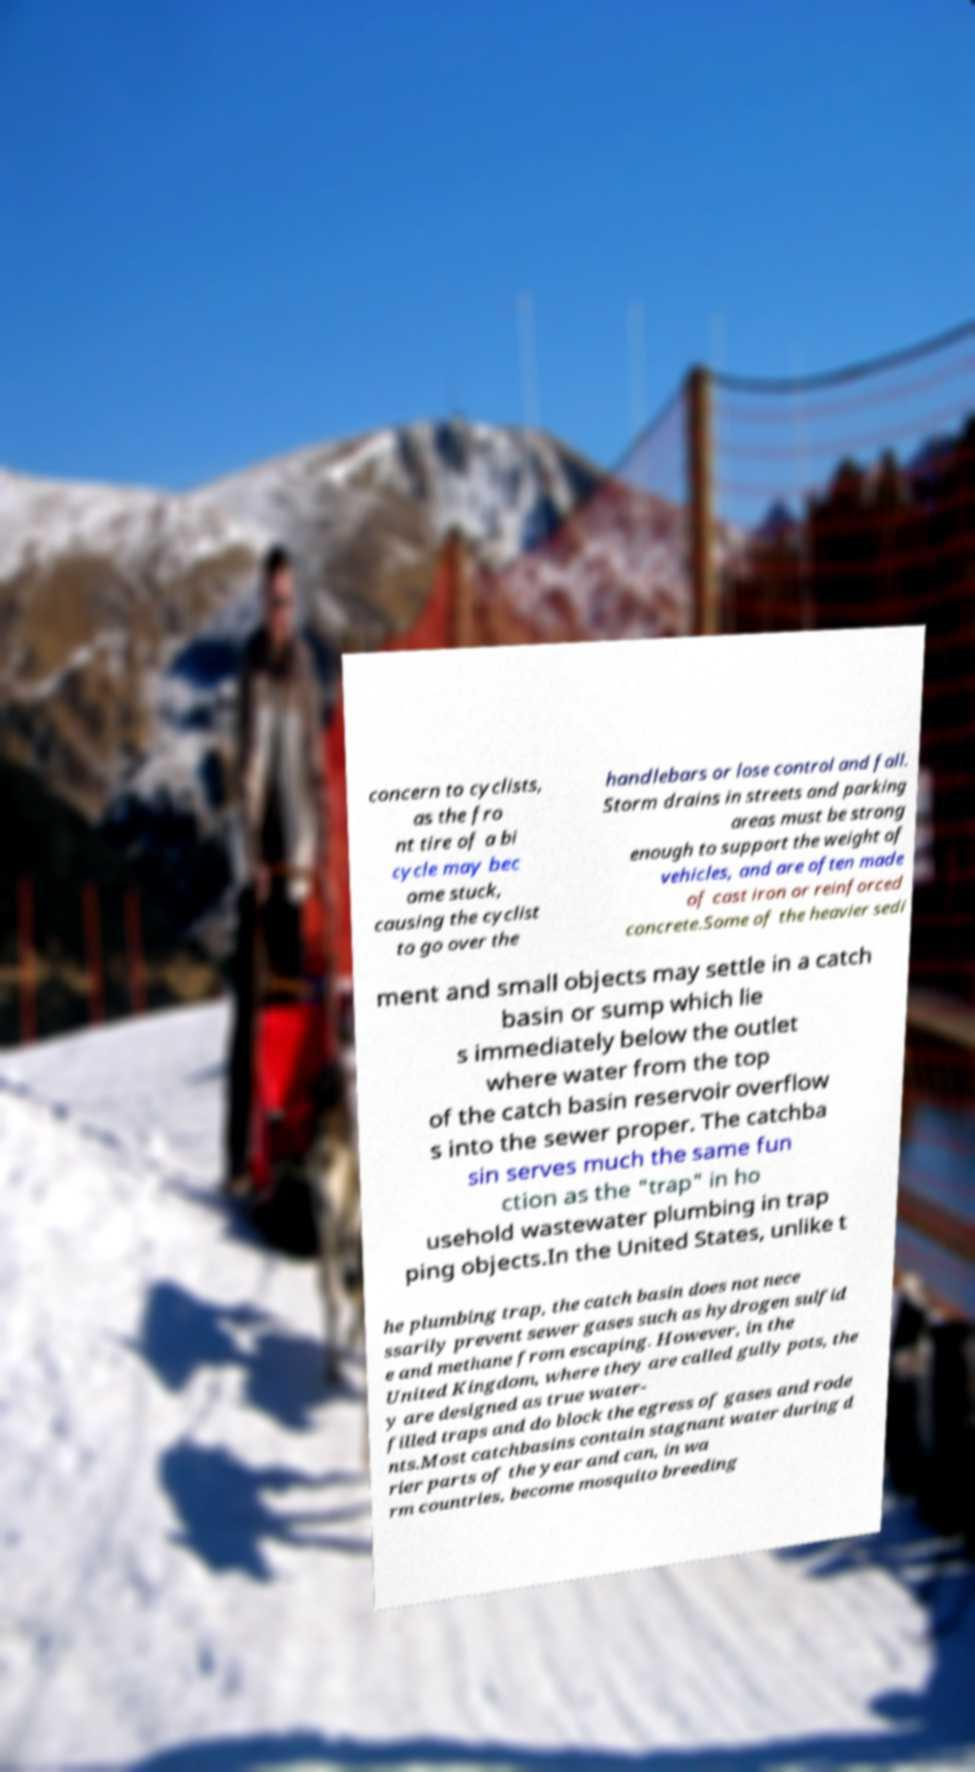Can you accurately transcribe the text from the provided image for me? concern to cyclists, as the fro nt tire of a bi cycle may bec ome stuck, causing the cyclist to go over the handlebars or lose control and fall. Storm drains in streets and parking areas must be strong enough to support the weight of vehicles, and are often made of cast iron or reinforced concrete.Some of the heavier sedi ment and small objects may settle in a catch basin or sump which lie s immediately below the outlet where water from the top of the catch basin reservoir overflow s into the sewer proper. The catchba sin serves much the same fun ction as the "trap" in ho usehold wastewater plumbing in trap ping objects.In the United States, unlike t he plumbing trap, the catch basin does not nece ssarily prevent sewer gases such as hydrogen sulfid e and methane from escaping. However, in the United Kingdom, where they are called gully pots, the y are designed as true water- filled traps and do block the egress of gases and rode nts.Most catchbasins contain stagnant water during d rier parts of the year and can, in wa rm countries, become mosquito breeding 